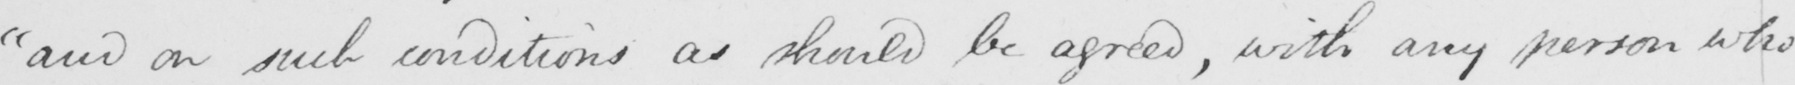What is written in this line of handwriting? "and on such conditions as should be agreed, with any person who 